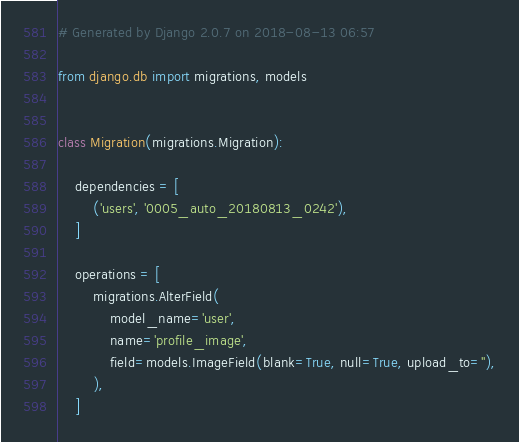Convert code to text. <code><loc_0><loc_0><loc_500><loc_500><_Python_># Generated by Django 2.0.7 on 2018-08-13 06:57

from django.db import migrations, models


class Migration(migrations.Migration):

    dependencies = [
        ('users', '0005_auto_20180813_0242'),
    ]

    operations = [
        migrations.AlterField(
            model_name='user',
            name='profile_image',
            field=models.ImageField(blank=True, null=True, upload_to=''),
        ),
    ]
</code> 